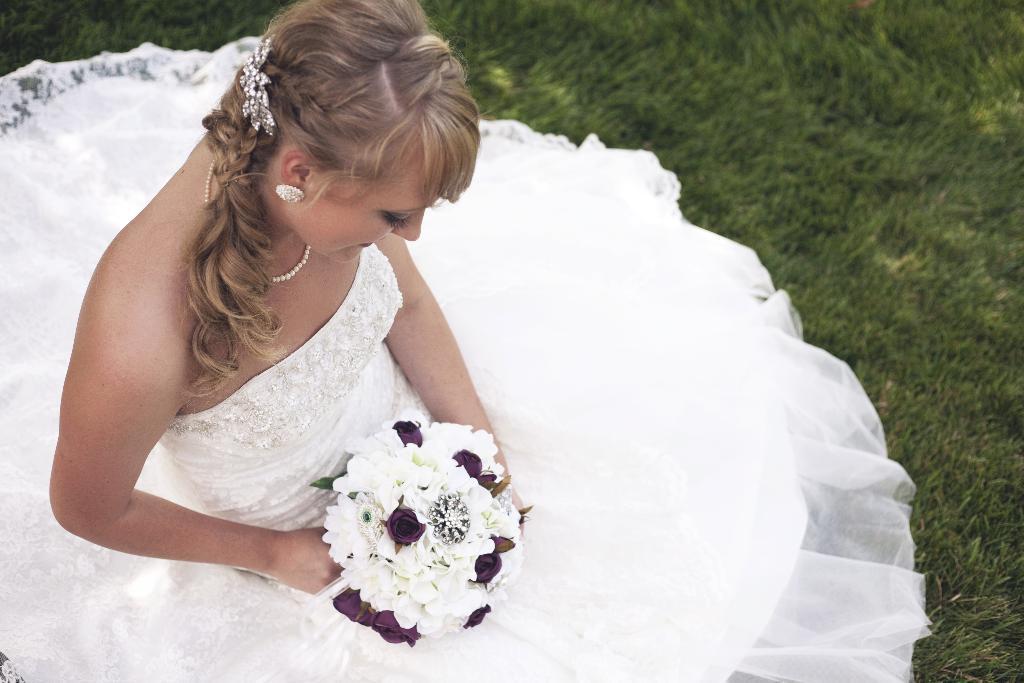Please provide a concise description of this image. In this picture there is a girl who is sitting on the left side of the image, on the grassland, by holding the flowers in her hands. 